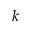Convert formula to latex. <formula><loc_0><loc_0><loc_500><loc_500>k</formula> 